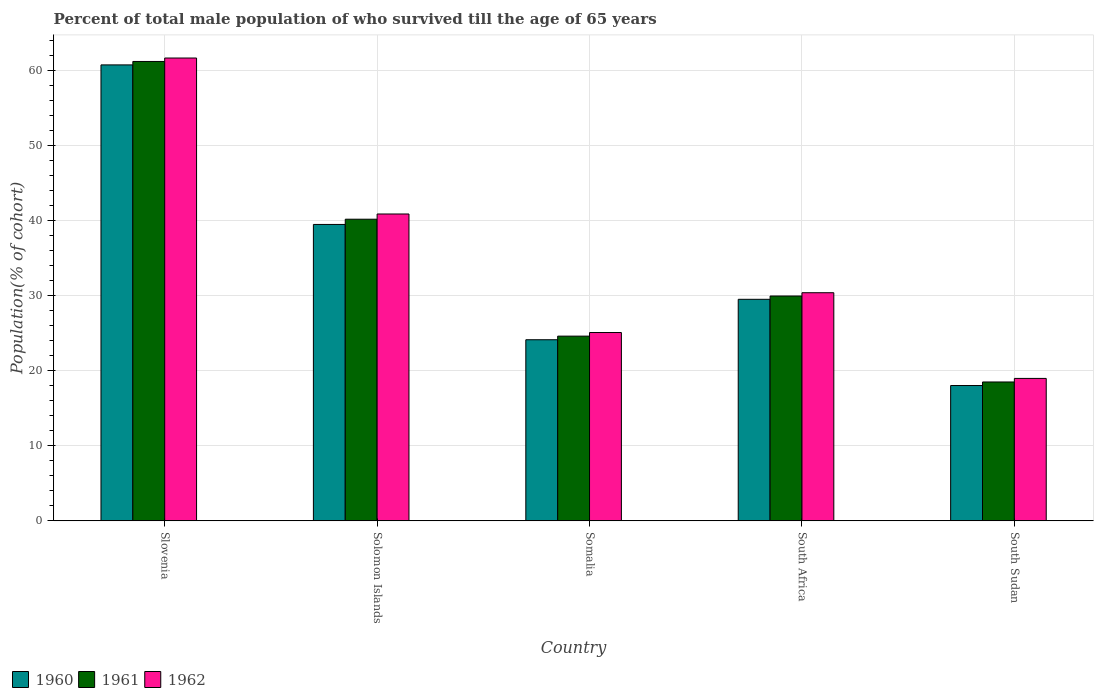How many different coloured bars are there?
Provide a succinct answer. 3. Are the number of bars per tick equal to the number of legend labels?
Your answer should be very brief. Yes. How many bars are there on the 5th tick from the left?
Your answer should be very brief. 3. How many bars are there on the 2nd tick from the right?
Ensure brevity in your answer.  3. What is the label of the 3rd group of bars from the left?
Offer a very short reply. Somalia. In how many cases, is the number of bars for a given country not equal to the number of legend labels?
Your answer should be very brief. 0. What is the percentage of total male population who survived till the age of 65 years in 1960 in South Sudan?
Your answer should be compact. 18.01. Across all countries, what is the maximum percentage of total male population who survived till the age of 65 years in 1962?
Provide a succinct answer. 61.6. Across all countries, what is the minimum percentage of total male population who survived till the age of 65 years in 1960?
Give a very brief answer. 18.01. In which country was the percentage of total male population who survived till the age of 65 years in 1962 maximum?
Make the answer very short. Slovenia. In which country was the percentage of total male population who survived till the age of 65 years in 1962 minimum?
Offer a terse response. South Sudan. What is the total percentage of total male population who survived till the age of 65 years in 1960 in the graph?
Provide a succinct answer. 171.74. What is the difference between the percentage of total male population who survived till the age of 65 years in 1961 in South Africa and that in South Sudan?
Your response must be concise. 11.44. What is the difference between the percentage of total male population who survived till the age of 65 years in 1962 in Somalia and the percentage of total male population who survived till the age of 65 years in 1960 in South Sudan?
Your answer should be compact. 7.06. What is the average percentage of total male population who survived till the age of 65 years in 1960 per country?
Your answer should be compact. 34.35. What is the difference between the percentage of total male population who survived till the age of 65 years of/in 1962 and percentage of total male population who survived till the age of 65 years of/in 1960 in Solomon Islands?
Give a very brief answer. 1.39. What is the ratio of the percentage of total male population who survived till the age of 65 years in 1962 in Solomon Islands to that in South Sudan?
Provide a succinct answer. 2.15. Is the percentage of total male population who survived till the age of 65 years in 1960 in Solomon Islands less than that in South Sudan?
Make the answer very short. No. Is the difference between the percentage of total male population who survived till the age of 65 years in 1962 in Slovenia and South Africa greater than the difference between the percentage of total male population who survived till the age of 65 years in 1960 in Slovenia and South Africa?
Provide a succinct answer. Yes. What is the difference between the highest and the second highest percentage of total male population who survived till the age of 65 years in 1962?
Provide a succinct answer. -20.76. What is the difference between the highest and the lowest percentage of total male population who survived till the age of 65 years in 1961?
Offer a terse response. 42.66. What does the 2nd bar from the left in South Sudan represents?
Keep it short and to the point. 1961. What does the 2nd bar from the right in Slovenia represents?
Offer a terse response. 1961. How many bars are there?
Your answer should be compact. 15. Are all the bars in the graph horizontal?
Give a very brief answer. No. How many countries are there in the graph?
Keep it short and to the point. 5. What is the difference between two consecutive major ticks on the Y-axis?
Your answer should be very brief. 10. Are the values on the major ticks of Y-axis written in scientific E-notation?
Your response must be concise. No. Does the graph contain any zero values?
Give a very brief answer. No. How are the legend labels stacked?
Provide a succinct answer. Horizontal. What is the title of the graph?
Offer a very short reply. Percent of total male population of who survived till the age of 65 years. Does "2004" appear as one of the legend labels in the graph?
Your answer should be compact. No. What is the label or title of the Y-axis?
Give a very brief answer. Population(% of cohort). What is the Population(% of cohort) of 1960 in Slovenia?
Offer a terse response. 60.69. What is the Population(% of cohort) in 1961 in Slovenia?
Give a very brief answer. 61.15. What is the Population(% of cohort) of 1962 in Slovenia?
Your response must be concise. 61.6. What is the Population(% of cohort) of 1960 in Solomon Islands?
Offer a very short reply. 39.45. What is the Population(% of cohort) of 1961 in Solomon Islands?
Your response must be concise. 40.15. What is the Population(% of cohort) in 1962 in Solomon Islands?
Provide a succinct answer. 40.84. What is the Population(% of cohort) in 1960 in Somalia?
Your answer should be very brief. 24.1. What is the Population(% of cohort) of 1961 in Somalia?
Your answer should be compact. 24.58. What is the Population(% of cohort) of 1962 in Somalia?
Your answer should be compact. 25.07. What is the Population(% of cohort) of 1960 in South Africa?
Give a very brief answer. 29.49. What is the Population(% of cohort) in 1961 in South Africa?
Offer a very short reply. 29.92. What is the Population(% of cohort) in 1962 in South Africa?
Offer a terse response. 30.36. What is the Population(% of cohort) in 1960 in South Sudan?
Provide a short and direct response. 18.01. What is the Population(% of cohort) in 1961 in South Sudan?
Provide a short and direct response. 18.48. What is the Population(% of cohort) in 1962 in South Sudan?
Give a very brief answer. 18.96. Across all countries, what is the maximum Population(% of cohort) of 1960?
Provide a succinct answer. 60.69. Across all countries, what is the maximum Population(% of cohort) of 1961?
Offer a very short reply. 61.15. Across all countries, what is the maximum Population(% of cohort) in 1962?
Provide a short and direct response. 61.6. Across all countries, what is the minimum Population(% of cohort) in 1960?
Offer a very short reply. 18.01. Across all countries, what is the minimum Population(% of cohort) in 1961?
Provide a short and direct response. 18.48. Across all countries, what is the minimum Population(% of cohort) of 1962?
Your response must be concise. 18.96. What is the total Population(% of cohort) in 1960 in the graph?
Your answer should be compact. 171.74. What is the total Population(% of cohort) in 1961 in the graph?
Ensure brevity in your answer.  174.28. What is the total Population(% of cohort) of 1962 in the graph?
Your answer should be compact. 176.83. What is the difference between the Population(% of cohort) of 1960 in Slovenia and that in Solomon Islands?
Provide a succinct answer. 21.24. What is the difference between the Population(% of cohort) of 1961 in Slovenia and that in Solomon Islands?
Make the answer very short. 21. What is the difference between the Population(% of cohort) of 1962 in Slovenia and that in Solomon Islands?
Provide a short and direct response. 20.76. What is the difference between the Population(% of cohort) in 1960 in Slovenia and that in Somalia?
Your response must be concise. 36.58. What is the difference between the Population(% of cohort) in 1961 in Slovenia and that in Somalia?
Provide a succinct answer. 36.56. What is the difference between the Population(% of cohort) in 1962 in Slovenia and that in Somalia?
Offer a terse response. 36.54. What is the difference between the Population(% of cohort) in 1960 in Slovenia and that in South Africa?
Your response must be concise. 31.2. What is the difference between the Population(% of cohort) in 1961 in Slovenia and that in South Africa?
Provide a short and direct response. 31.22. What is the difference between the Population(% of cohort) of 1962 in Slovenia and that in South Africa?
Offer a very short reply. 31.24. What is the difference between the Population(% of cohort) in 1960 in Slovenia and that in South Sudan?
Give a very brief answer. 42.68. What is the difference between the Population(% of cohort) in 1961 in Slovenia and that in South Sudan?
Offer a very short reply. 42.66. What is the difference between the Population(% of cohort) of 1962 in Slovenia and that in South Sudan?
Offer a terse response. 42.65. What is the difference between the Population(% of cohort) of 1960 in Solomon Islands and that in Somalia?
Offer a very short reply. 15.35. What is the difference between the Population(% of cohort) in 1961 in Solomon Islands and that in Somalia?
Your answer should be compact. 15.56. What is the difference between the Population(% of cohort) of 1962 in Solomon Islands and that in Somalia?
Provide a short and direct response. 15.78. What is the difference between the Population(% of cohort) of 1960 in Solomon Islands and that in South Africa?
Offer a terse response. 9.96. What is the difference between the Population(% of cohort) in 1961 in Solomon Islands and that in South Africa?
Your answer should be compact. 10.22. What is the difference between the Population(% of cohort) of 1962 in Solomon Islands and that in South Africa?
Your answer should be very brief. 10.48. What is the difference between the Population(% of cohort) in 1960 in Solomon Islands and that in South Sudan?
Your answer should be very brief. 21.44. What is the difference between the Population(% of cohort) in 1961 in Solomon Islands and that in South Sudan?
Offer a very short reply. 21.66. What is the difference between the Population(% of cohort) in 1962 in Solomon Islands and that in South Sudan?
Offer a terse response. 21.89. What is the difference between the Population(% of cohort) in 1960 in Somalia and that in South Africa?
Keep it short and to the point. -5.38. What is the difference between the Population(% of cohort) in 1961 in Somalia and that in South Africa?
Offer a very short reply. -5.34. What is the difference between the Population(% of cohort) in 1962 in Somalia and that in South Africa?
Your answer should be very brief. -5.3. What is the difference between the Population(% of cohort) of 1960 in Somalia and that in South Sudan?
Your answer should be compact. 6.1. What is the difference between the Population(% of cohort) of 1961 in Somalia and that in South Sudan?
Your response must be concise. 6.1. What is the difference between the Population(% of cohort) of 1962 in Somalia and that in South Sudan?
Make the answer very short. 6.11. What is the difference between the Population(% of cohort) of 1960 in South Africa and that in South Sudan?
Ensure brevity in your answer.  11.48. What is the difference between the Population(% of cohort) in 1961 in South Africa and that in South Sudan?
Make the answer very short. 11.44. What is the difference between the Population(% of cohort) in 1962 in South Africa and that in South Sudan?
Your answer should be very brief. 11.41. What is the difference between the Population(% of cohort) in 1960 in Slovenia and the Population(% of cohort) in 1961 in Solomon Islands?
Offer a very short reply. 20.54. What is the difference between the Population(% of cohort) of 1960 in Slovenia and the Population(% of cohort) of 1962 in Solomon Islands?
Provide a succinct answer. 19.84. What is the difference between the Population(% of cohort) of 1961 in Slovenia and the Population(% of cohort) of 1962 in Solomon Islands?
Offer a terse response. 20.3. What is the difference between the Population(% of cohort) of 1960 in Slovenia and the Population(% of cohort) of 1961 in Somalia?
Your response must be concise. 36.1. What is the difference between the Population(% of cohort) in 1960 in Slovenia and the Population(% of cohort) in 1962 in Somalia?
Make the answer very short. 35.62. What is the difference between the Population(% of cohort) in 1961 in Slovenia and the Population(% of cohort) in 1962 in Somalia?
Ensure brevity in your answer.  36.08. What is the difference between the Population(% of cohort) of 1960 in Slovenia and the Population(% of cohort) of 1961 in South Africa?
Give a very brief answer. 30.76. What is the difference between the Population(% of cohort) in 1960 in Slovenia and the Population(% of cohort) in 1962 in South Africa?
Ensure brevity in your answer.  30.33. What is the difference between the Population(% of cohort) of 1961 in Slovenia and the Population(% of cohort) of 1962 in South Africa?
Provide a succinct answer. 30.78. What is the difference between the Population(% of cohort) in 1960 in Slovenia and the Population(% of cohort) in 1961 in South Sudan?
Offer a terse response. 42.21. What is the difference between the Population(% of cohort) in 1960 in Slovenia and the Population(% of cohort) in 1962 in South Sudan?
Offer a very short reply. 41.73. What is the difference between the Population(% of cohort) of 1961 in Slovenia and the Population(% of cohort) of 1962 in South Sudan?
Your answer should be compact. 42.19. What is the difference between the Population(% of cohort) in 1960 in Solomon Islands and the Population(% of cohort) in 1961 in Somalia?
Offer a very short reply. 14.87. What is the difference between the Population(% of cohort) of 1960 in Solomon Islands and the Population(% of cohort) of 1962 in Somalia?
Provide a short and direct response. 14.39. What is the difference between the Population(% of cohort) of 1961 in Solomon Islands and the Population(% of cohort) of 1962 in Somalia?
Make the answer very short. 15.08. What is the difference between the Population(% of cohort) in 1960 in Solomon Islands and the Population(% of cohort) in 1961 in South Africa?
Make the answer very short. 9.53. What is the difference between the Population(% of cohort) of 1960 in Solomon Islands and the Population(% of cohort) of 1962 in South Africa?
Offer a very short reply. 9.09. What is the difference between the Population(% of cohort) of 1961 in Solomon Islands and the Population(% of cohort) of 1962 in South Africa?
Give a very brief answer. 9.78. What is the difference between the Population(% of cohort) in 1960 in Solomon Islands and the Population(% of cohort) in 1961 in South Sudan?
Offer a terse response. 20.97. What is the difference between the Population(% of cohort) of 1960 in Solomon Islands and the Population(% of cohort) of 1962 in South Sudan?
Provide a succinct answer. 20.49. What is the difference between the Population(% of cohort) of 1961 in Solomon Islands and the Population(% of cohort) of 1962 in South Sudan?
Ensure brevity in your answer.  21.19. What is the difference between the Population(% of cohort) of 1960 in Somalia and the Population(% of cohort) of 1961 in South Africa?
Keep it short and to the point. -5.82. What is the difference between the Population(% of cohort) in 1960 in Somalia and the Population(% of cohort) in 1962 in South Africa?
Offer a terse response. -6.26. What is the difference between the Population(% of cohort) in 1961 in Somalia and the Population(% of cohort) in 1962 in South Africa?
Keep it short and to the point. -5.78. What is the difference between the Population(% of cohort) of 1960 in Somalia and the Population(% of cohort) of 1961 in South Sudan?
Provide a short and direct response. 5.62. What is the difference between the Population(% of cohort) in 1960 in Somalia and the Population(% of cohort) in 1962 in South Sudan?
Provide a succinct answer. 5.15. What is the difference between the Population(% of cohort) of 1961 in Somalia and the Population(% of cohort) of 1962 in South Sudan?
Your answer should be compact. 5.63. What is the difference between the Population(% of cohort) in 1960 in South Africa and the Population(% of cohort) in 1961 in South Sudan?
Your answer should be very brief. 11. What is the difference between the Population(% of cohort) in 1960 in South Africa and the Population(% of cohort) in 1962 in South Sudan?
Provide a short and direct response. 10.53. What is the difference between the Population(% of cohort) in 1961 in South Africa and the Population(% of cohort) in 1962 in South Sudan?
Keep it short and to the point. 10.97. What is the average Population(% of cohort) of 1960 per country?
Your answer should be very brief. 34.35. What is the average Population(% of cohort) in 1961 per country?
Provide a succinct answer. 34.86. What is the average Population(% of cohort) of 1962 per country?
Your response must be concise. 35.37. What is the difference between the Population(% of cohort) of 1960 and Population(% of cohort) of 1961 in Slovenia?
Ensure brevity in your answer.  -0.46. What is the difference between the Population(% of cohort) of 1960 and Population(% of cohort) of 1962 in Slovenia?
Make the answer very short. -0.92. What is the difference between the Population(% of cohort) of 1961 and Population(% of cohort) of 1962 in Slovenia?
Make the answer very short. -0.46. What is the difference between the Population(% of cohort) in 1960 and Population(% of cohort) in 1961 in Solomon Islands?
Make the answer very short. -0.7. What is the difference between the Population(% of cohort) of 1960 and Population(% of cohort) of 1962 in Solomon Islands?
Make the answer very short. -1.39. What is the difference between the Population(% of cohort) of 1961 and Population(% of cohort) of 1962 in Solomon Islands?
Your answer should be compact. -0.7. What is the difference between the Population(% of cohort) of 1960 and Population(% of cohort) of 1961 in Somalia?
Provide a short and direct response. -0.48. What is the difference between the Population(% of cohort) of 1960 and Population(% of cohort) of 1962 in Somalia?
Your answer should be compact. -0.96. What is the difference between the Population(% of cohort) in 1961 and Population(% of cohort) in 1962 in Somalia?
Provide a short and direct response. -0.48. What is the difference between the Population(% of cohort) of 1960 and Population(% of cohort) of 1961 in South Africa?
Keep it short and to the point. -0.44. What is the difference between the Population(% of cohort) of 1960 and Population(% of cohort) of 1962 in South Africa?
Your answer should be very brief. -0.88. What is the difference between the Population(% of cohort) of 1961 and Population(% of cohort) of 1962 in South Africa?
Offer a terse response. -0.44. What is the difference between the Population(% of cohort) of 1960 and Population(% of cohort) of 1961 in South Sudan?
Keep it short and to the point. -0.47. What is the difference between the Population(% of cohort) in 1960 and Population(% of cohort) in 1962 in South Sudan?
Give a very brief answer. -0.95. What is the difference between the Population(% of cohort) in 1961 and Population(% of cohort) in 1962 in South Sudan?
Provide a succinct answer. -0.47. What is the ratio of the Population(% of cohort) in 1960 in Slovenia to that in Solomon Islands?
Your answer should be compact. 1.54. What is the ratio of the Population(% of cohort) of 1961 in Slovenia to that in Solomon Islands?
Provide a succinct answer. 1.52. What is the ratio of the Population(% of cohort) in 1962 in Slovenia to that in Solomon Islands?
Offer a very short reply. 1.51. What is the ratio of the Population(% of cohort) in 1960 in Slovenia to that in Somalia?
Your answer should be compact. 2.52. What is the ratio of the Population(% of cohort) of 1961 in Slovenia to that in Somalia?
Offer a very short reply. 2.49. What is the ratio of the Population(% of cohort) of 1962 in Slovenia to that in Somalia?
Offer a very short reply. 2.46. What is the ratio of the Population(% of cohort) of 1960 in Slovenia to that in South Africa?
Provide a short and direct response. 2.06. What is the ratio of the Population(% of cohort) of 1961 in Slovenia to that in South Africa?
Provide a succinct answer. 2.04. What is the ratio of the Population(% of cohort) of 1962 in Slovenia to that in South Africa?
Your answer should be very brief. 2.03. What is the ratio of the Population(% of cohort) of 1960 in Slovenia to that in South Sudan?
Your answer should be very brief. 3.37. What is the ratio of the Population(% of cohort) of 1961 in Slovenia to that in South Sudan?
Provide a short and direct response. 3.31. What is the ratio of the Population(% of cohort) in 1962 in Slovenia to that in South Sudan?
Ensure brevity in your answer.  3.25. What is the ratio of the Population(% of cohort) in 1960 in Solomon Islands to that in Somalia?
Ensure brevity in your answer.  1.64. What is the ratio of the Population(% of cohort) in 1961 in Solomon Islands to that in Somalia?
Ensure brevity in your answer.  1.63. What is the ratio of the Population(% of cohort) of 1962 in Solomon Islands to that in Somalia?
Your answer should be very brief. 1.63. What is the ratio of the Population(% of cohort) of 1960 in Solomon Islands to that in South Africa?
Offer a terse response. 1.34. What is the ratio of the Population(% of cohort) of 1961 in Solomon Islands to that in South Africa?
Your answer should be very brief. 1.34. What is the ratio of the Population(% of cohort) in 1962 in Solomon Islands to that in South Africa?
Make the answer very short. 1.35. What is the ratio of the Population(% of cohort) of 1960 in Solomon Islands to that in South Sudan?
Make the answer very short. 2.19. What is the ratio of the Population(% of cohort) of 1961 in Solomon Islands to that in South Sudan?
Provide a succinct answer. 2.17. What is the ratio of the Population(% of cohort) in 1962 in Solomon Islands to that in South Sudan?
Offer a terse response. 2.15. What is the ratio of the Population(% of cohort) of 1960 in Somalia to that in South Africa?
Keep it short and to the point. 0.82. What is the ratio of the Population(% of cohort) of 1961 in Somalia to that in South Africa?
Your response must be concise. 0.82. What is the ratio of the Population(% of cohort) in 1962 in Somalia to that in South Africa?
Keep it short and to the point. 0.83. What is the ratio of the Population(% of cohort) in 1960 in Somalia to that in South Sudan?
Offer a very short reply. 1.34. What is the ratio of the Population(% of cohort) of 1961 in Somalia to that in South Sudan?
Provide a succinct answer. 1.33. What is the ratio of the Population(% of cohort) of 1962 in Somalia to that in South Sudan?
Your response must be concise. 1.32. What is the ratio of the Population(% of cohort) in 1960 in South Africa to that in South Sudan?
Offer a terse response. 1.64. What is the ratio of the Population(% of cohort) in 1961 in South Africa to that in South Sudan?
Keep it short and to the point. 1.62. What is the ratio of the Population(% of cohort) of 1962 in South Africa to that in South Sudan?
Your answer should be compact. 1.6. What is the difference between the highest and the second highest Population(% of cohort) in 1960?
Offer a very short reply. 21.24. What is the difference between the highest and the second highest Population(% of cohort) of 1961?
Offer a terse response. 21. What is the difference between the highest and the second highest Population(% of cohort) in 1962?
Offer a terse response. 20.76. What is the difference between the highest and the lowest Population(% of cohort) in 1960?
Provide a short and direct response. 42.68. What is the difference between the highest and the lowest Population(% of cohort) in 1961?
Your answer should be very brief. 42.66. What is the difference between the highest and the lowest Population(% of cohort) in 1962?
Your answer should be compact. 42.65. 